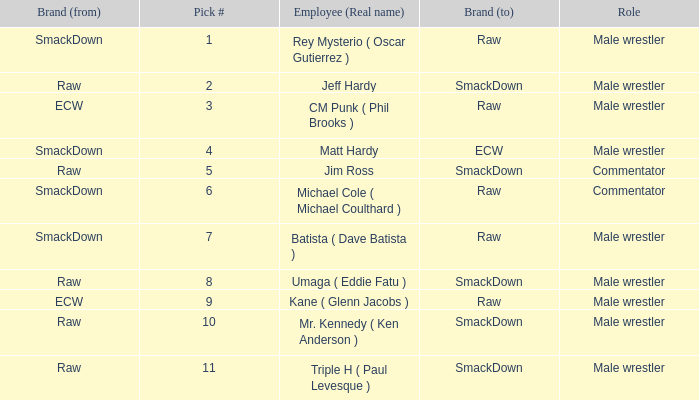What is the real name of the Pick # that is greater than 9? Mr. Kennedy ( Ken Anderson ), Triple H ( Paul Levesque ). 